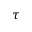Convert formula to latex. <formula><loc_0><loc_0><loc_500><loc_500>\tau</formula> 